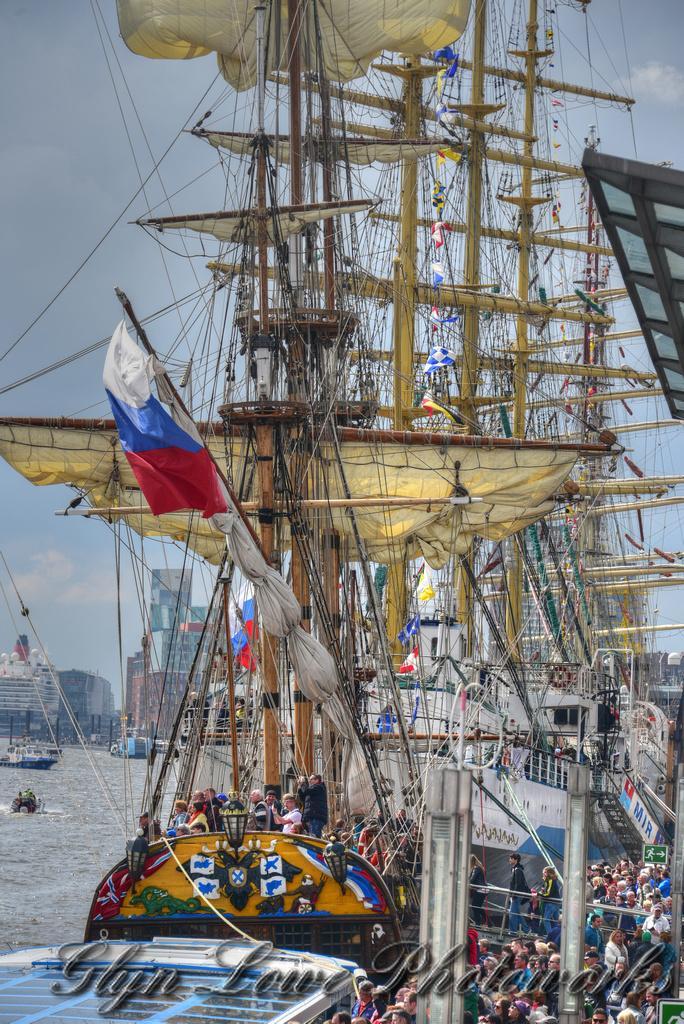In one or two sentences, can you explain what this image depicts? In this image, we can see some persons in the ship. There are boats in the bottom left of the image floating on the water. There are buildings on the left side of the image. In the background of the image, there is a sky. 